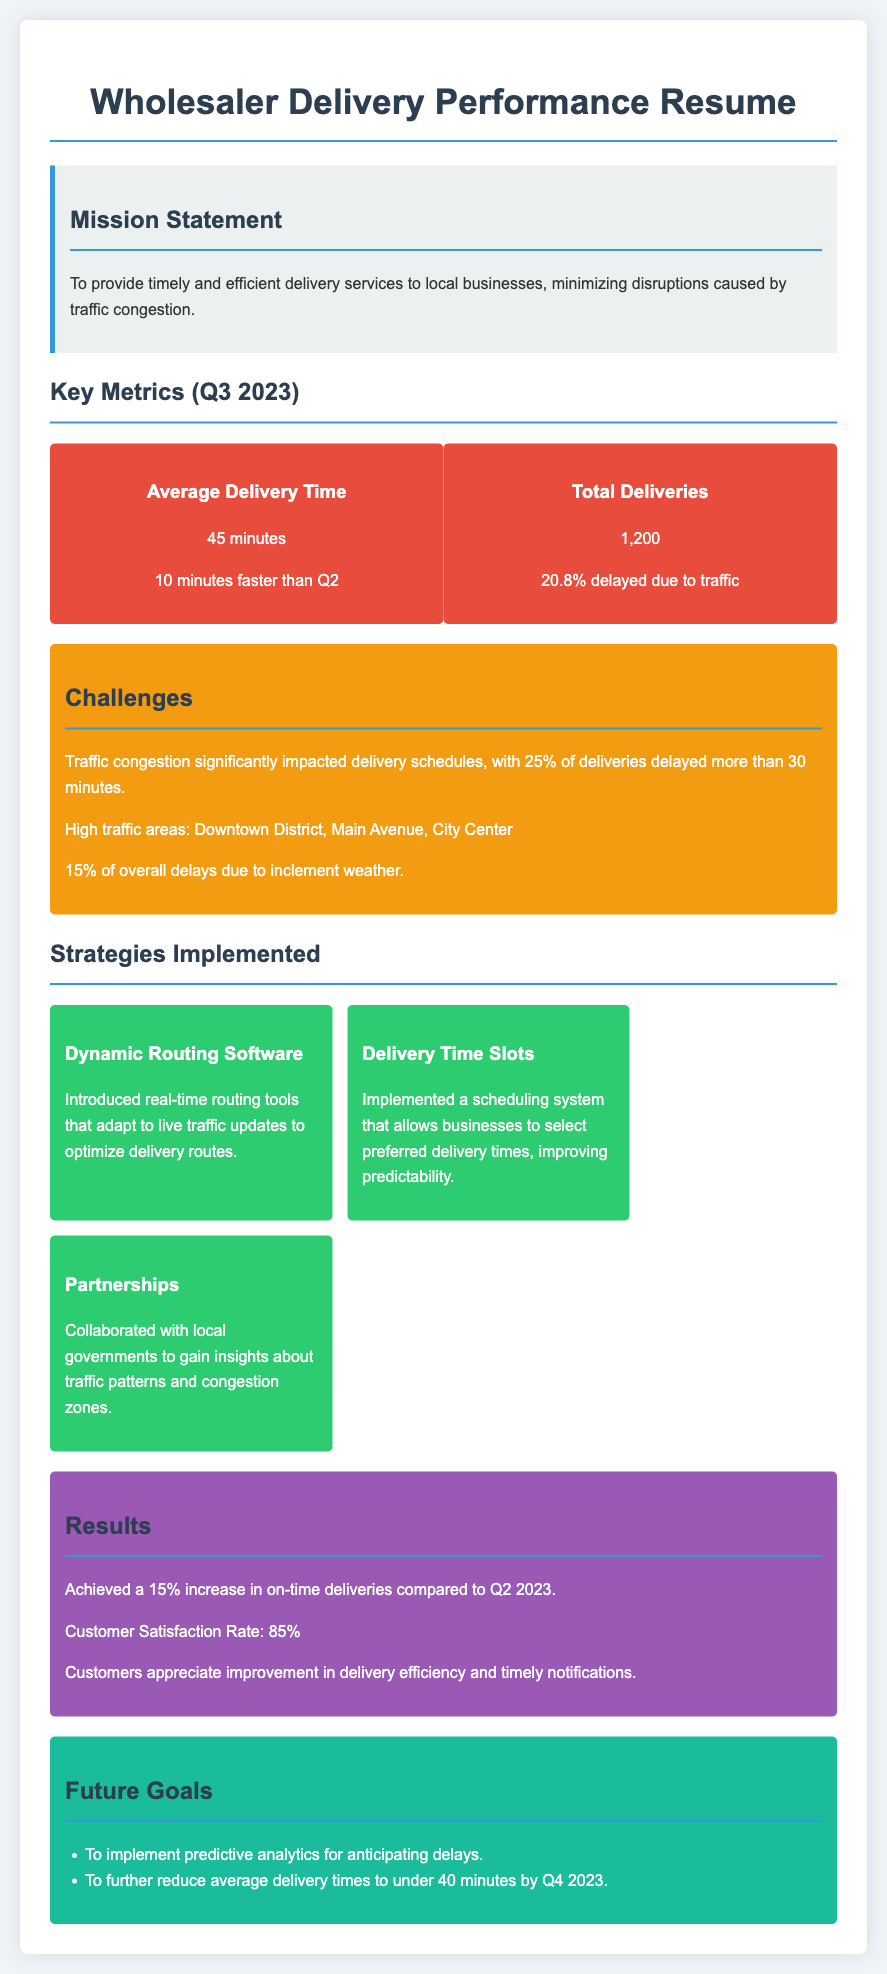what was the average delivery time? The average delivery time listed for Q3 2023 is found in the Key Metrics section, stated as 45 minutes.
Answer: 45 minutes how many total deliveries were made? The total number of deliveries can be found in the Key Metrics section, which indicates 1,200 total deliveries.
Answer: 1,200 what percentage of deliveries were delayed due to traffic? The document specifies that 20.8% of total deliveries were delayed due to traffic, found in the Key Metrics section.
Answer: 20.8% what was the increase in on-time deliveries compared to Q2? The Results section states that there was a 15% increase in on-time deliveries compared to Q2 2023.
Answer: 15% which area had significant traffic congestion affecting deliveries? The document highlights the Downtown District as a high traffic area affecting delivery schedules.
Answer: Downtown District how did the introduction of dynamic routing software help? The introduction of dynamic routing software was designed to optimize delivery routes based on live traffic updates, as explained in the Strategies Implemented section.
Answer: Optimize delivery routes what is the customer satisfaction rate? The Results section indicates that the customer satisfaction rate is stated as 85%.
Answer: 85% what future goal aims to reduce average delivery times? The document mentions a future goal to reduce average delivery times to under 40 minutes by Q4 2023.
Answer: Under 40 minutes what challenge was attributed to inclement weather? The document states that 15% of overall delays were due to inclement weather, which is listed in the Challenges section.
Answer: 15% 